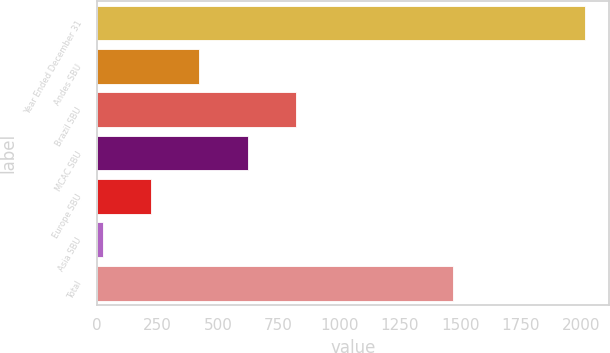Convert chart to OTSL. <chart><loc_0><loc_0><loc_500><loc_500><bar_chart><fcel>Year Ended December 31<fcel>Andes SBU<fcel>Brazil SBU<fcel>MCAC SBU<fcel>Europe SBU<fcel>Asia SBU<fcel>Total<nl><fcel>2014<fcel>422.8<fcel>820.6<fcel>621.7<fcel>223.9<fcel>25<fcel>1471<nl></chart> 